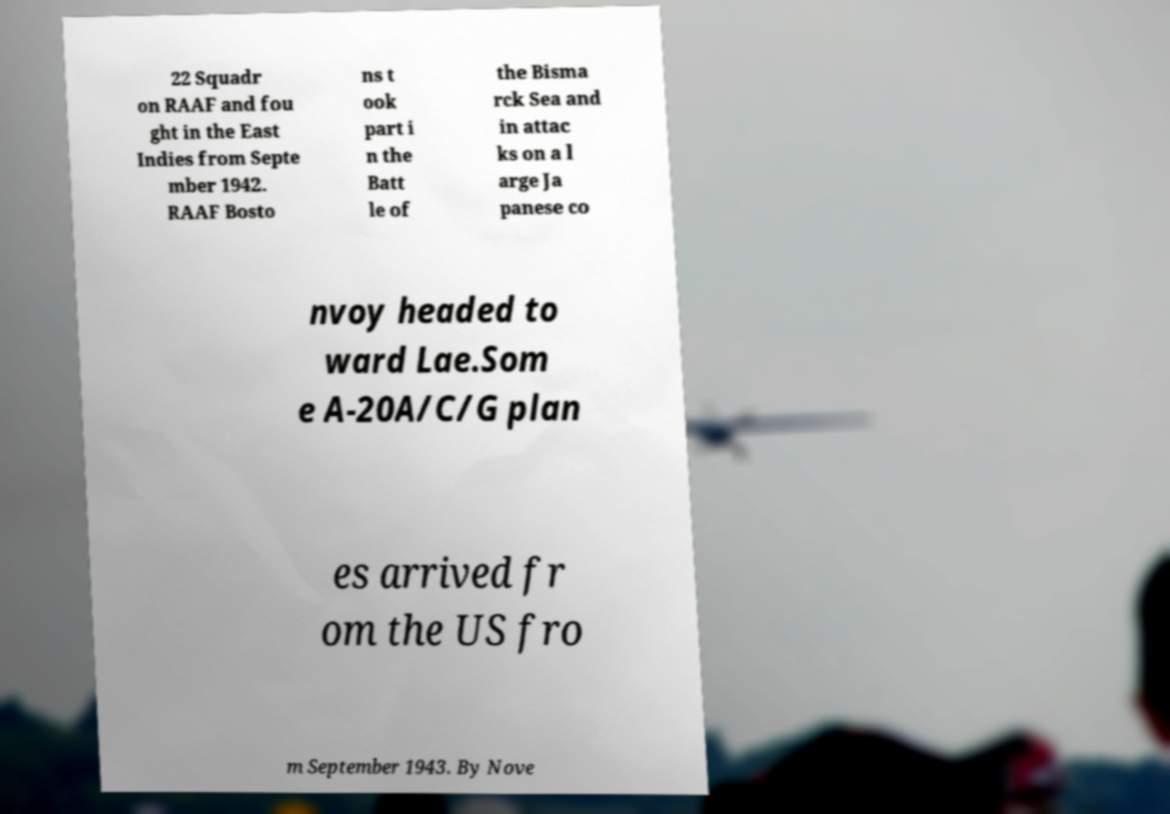Please read and relay the text visible in this image. What does it say? 22 Squadr on RAAF and fou ght in the East Indies from Septe mber 1942. RAAF Bosto ns t ook part i n the Batt le of the Bisma rck Sea and in attac ks on a l arge Ja panese co nvoy headed to ward Lae.Som e A-20A/C/G plan es arrived fr om the US fro m September 1943. By Nove 